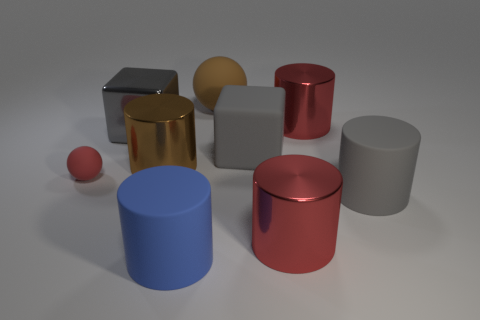Subtract all large red cylinders. How many cylinders are left? 3 Subtract all blue cylinders. How many cylinders are left? 4 Subtract all spheres. How many objects are left? 7 Subtract all brown metallic objects. Subtract all large shiny cylinders. How many objects are left? 5 Add 4 big gray rubber things. How many big gray rubber things are left? 6 Add 7 large gray metallic cylinders. How many large gray metallic cylinders exist? 7 Add 1 metallic balls. How many objects exist? 10 Subtract 1 brown balls. How many objects are left? 8 Subtract 1 balls. How many balls are left? 1 Subtract all purple blocks. Subtract all gray cylinders. How many blocks are left? 2 